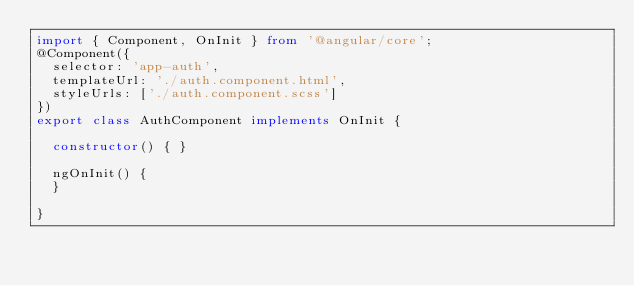Convert code to text. <code><loc_0><loc_0><loc_500><loc_500><_TypeScript_>import { Component, OnInit } from '@angular/core';
@Component({
  selector: 'app-auth',
  templateUrl: './auth.component.html',
  styleUrls: ['./auth.component.scss']
})
export class AuthComponent implements OnInit {

  constructor() { }

  ngOnInit() {
  }

}
</code> 